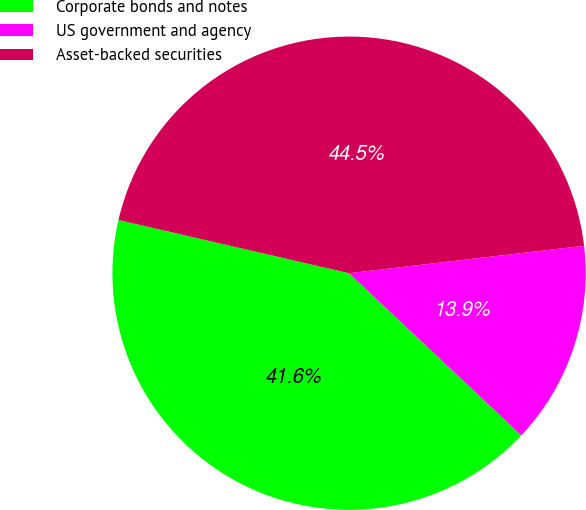Convert chart to OTSL. <chart><loc_0><loc_0><loc_500><loc_500><pie_chart><fcel>Corporate bonds and notes<fcel>US government and agency<fcel>Asset-backed securities<nl><fcel>41.59%<fcel>13.87%<fcel>44.54%<nl></chart> 